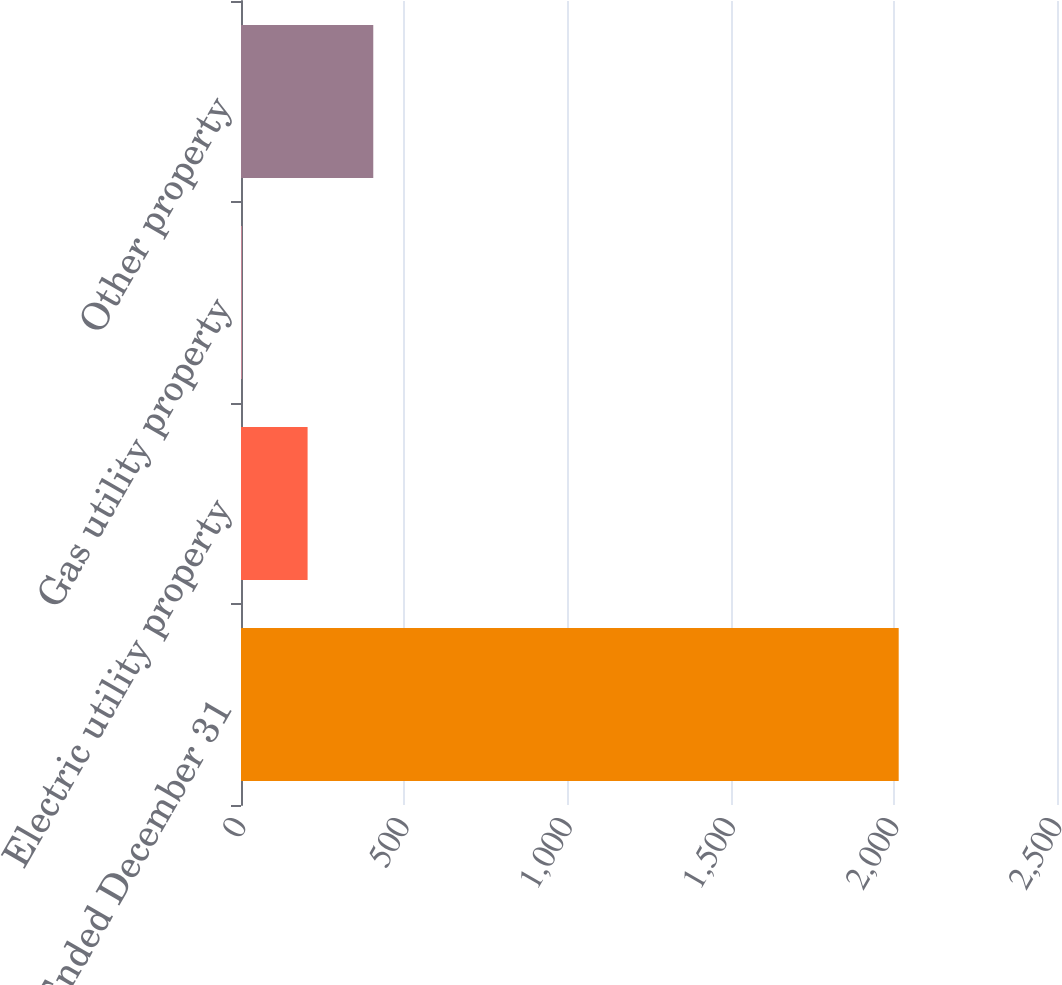Convert chart to OTSL. <chart><loc_0><loc_0><loc_500><loc_500><bar_chart><fcel>Years Ended December 31<fcel>Electric utility property<fcel>Gas utility property<fcel>Other property<nl><fcel>2015<fcel>204.02<fcel>2.8<fcel>405.24<nl></chart> 